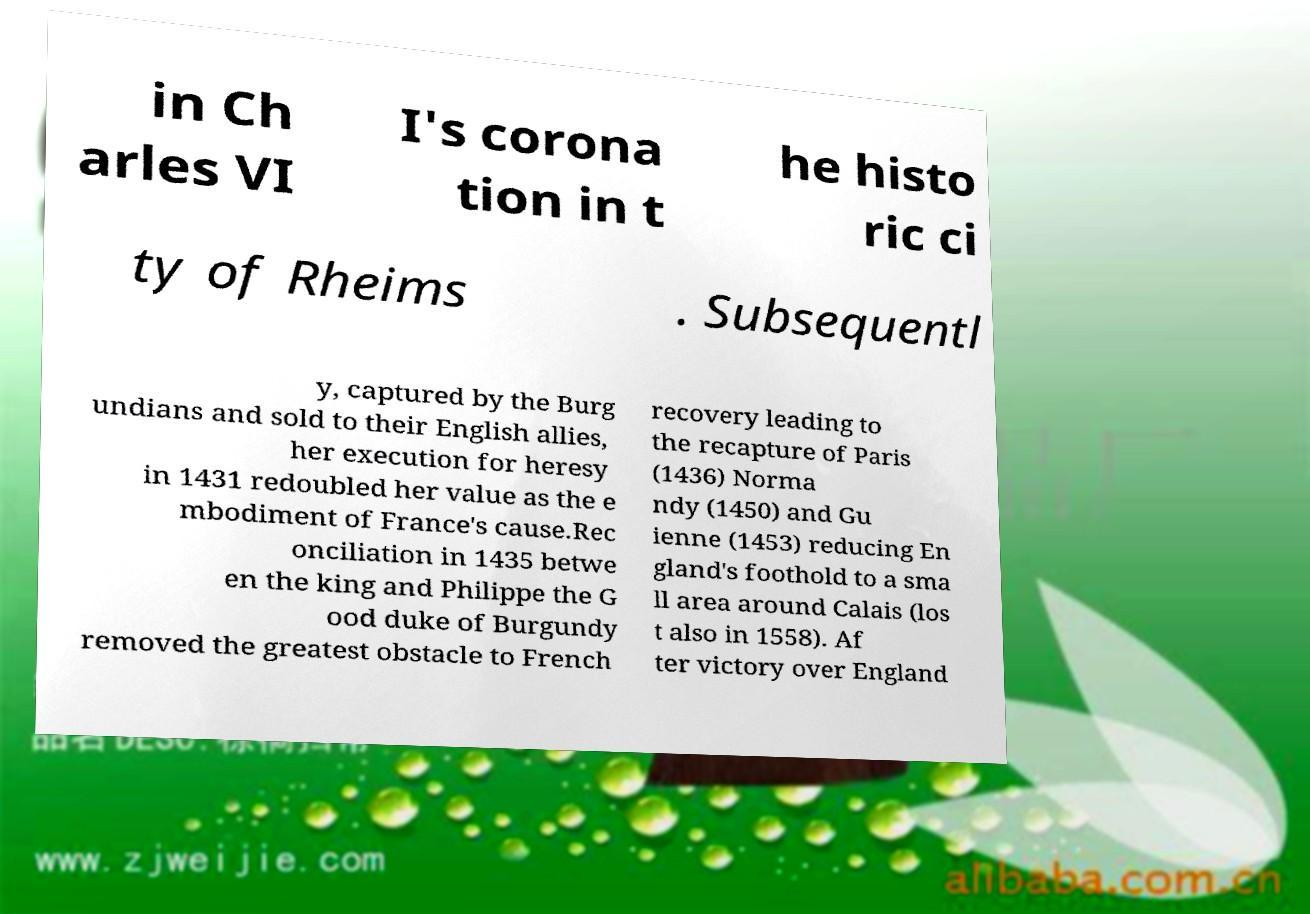Can you accurately transcribe the text from the provided image for me? in Ch arles VI I's corona tion in t he histo ric ci ty of Rheims . Subsequentl y, captured by the Burg undians and sold to their English allies, her execution for heresy in 1431 redoubled her value as the e mbodiment of France's cause.Rec onciliation in 1435 betwe en the king and Philippe the G ood duke of Burgundy removed the greatest obstacle to French recovery leading to the recapture of Paris (1436) Norma ndy (1450) and Gu ienne (1453) reducing En gland's foothold to a sma ll area around Calais (los t also in 1558). Af ter victory over England 